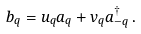Convert formula to latex. <formula><loc_0><loc_0><loc_500><loc_500>b _ { q } = u _ { q } a _ { q } + v _ { q } a _ { - { q } } ^ { \dagger } \, .</formula> 